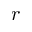Convert formula to latex. <formula><loc_0><loc_0><loc_500><loc_500>r</formula> 